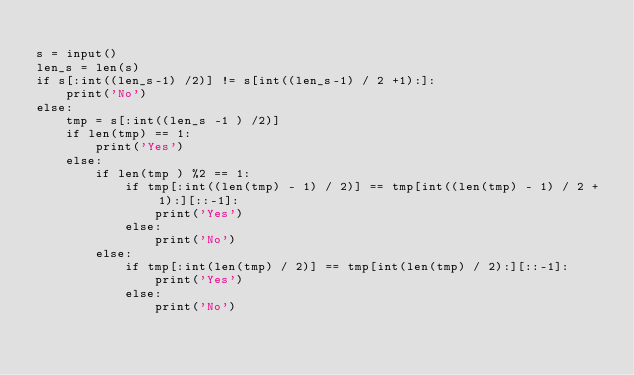<code> <loc_0><loc_0><loc_500><loc_500><_Python_>
s = input()
len_s = len(s)
if s[:int((len_s-1) /2)] != s[int((len_s-1) / 2 +1):]:
    print('No')
else:
    tmp = s[:int((len_s -1 ) /2)]
    if len(tmp) == 1:
        print('Yes')
    else:
        if len(tmp ) %2 == 1:
            if tmp[:int((len(tmp) - 1) / 2)] == tmp[int((len(tmp) - 1) / 2 + 1):][::-1]:
                print('Yes')
            else:
                print('No')
        else:
            if tmp[:int(len(tmp) / 2)] == tmp[int(len(tmp) / 2):][::-1]:
                print('Yes')
            else:
                print('No')
</code> 